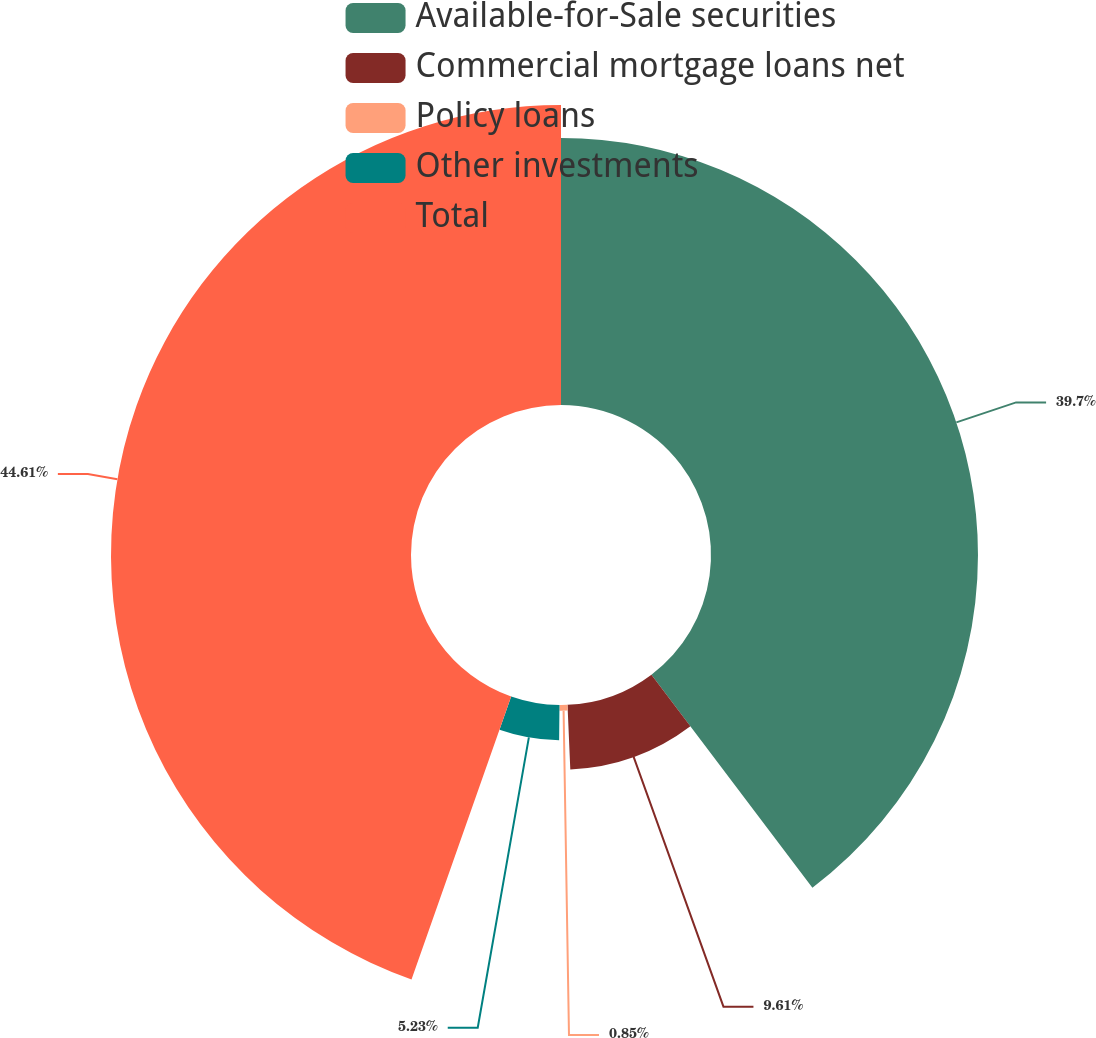Convert chart to OTSL. <chart><loc_0><loc_0><loc_500><loc_500><pie_chart><fcel>Available-for-Sale securities<fcel>Commercial mortgage loans net<fcel>Policy loans<fcel>Other investments<fcel>Total<nl><fcel>39.7%<fcel>9.61%<fcel>0.85%<fcel>5.23%<fcel>44.61%<nl></chart> 